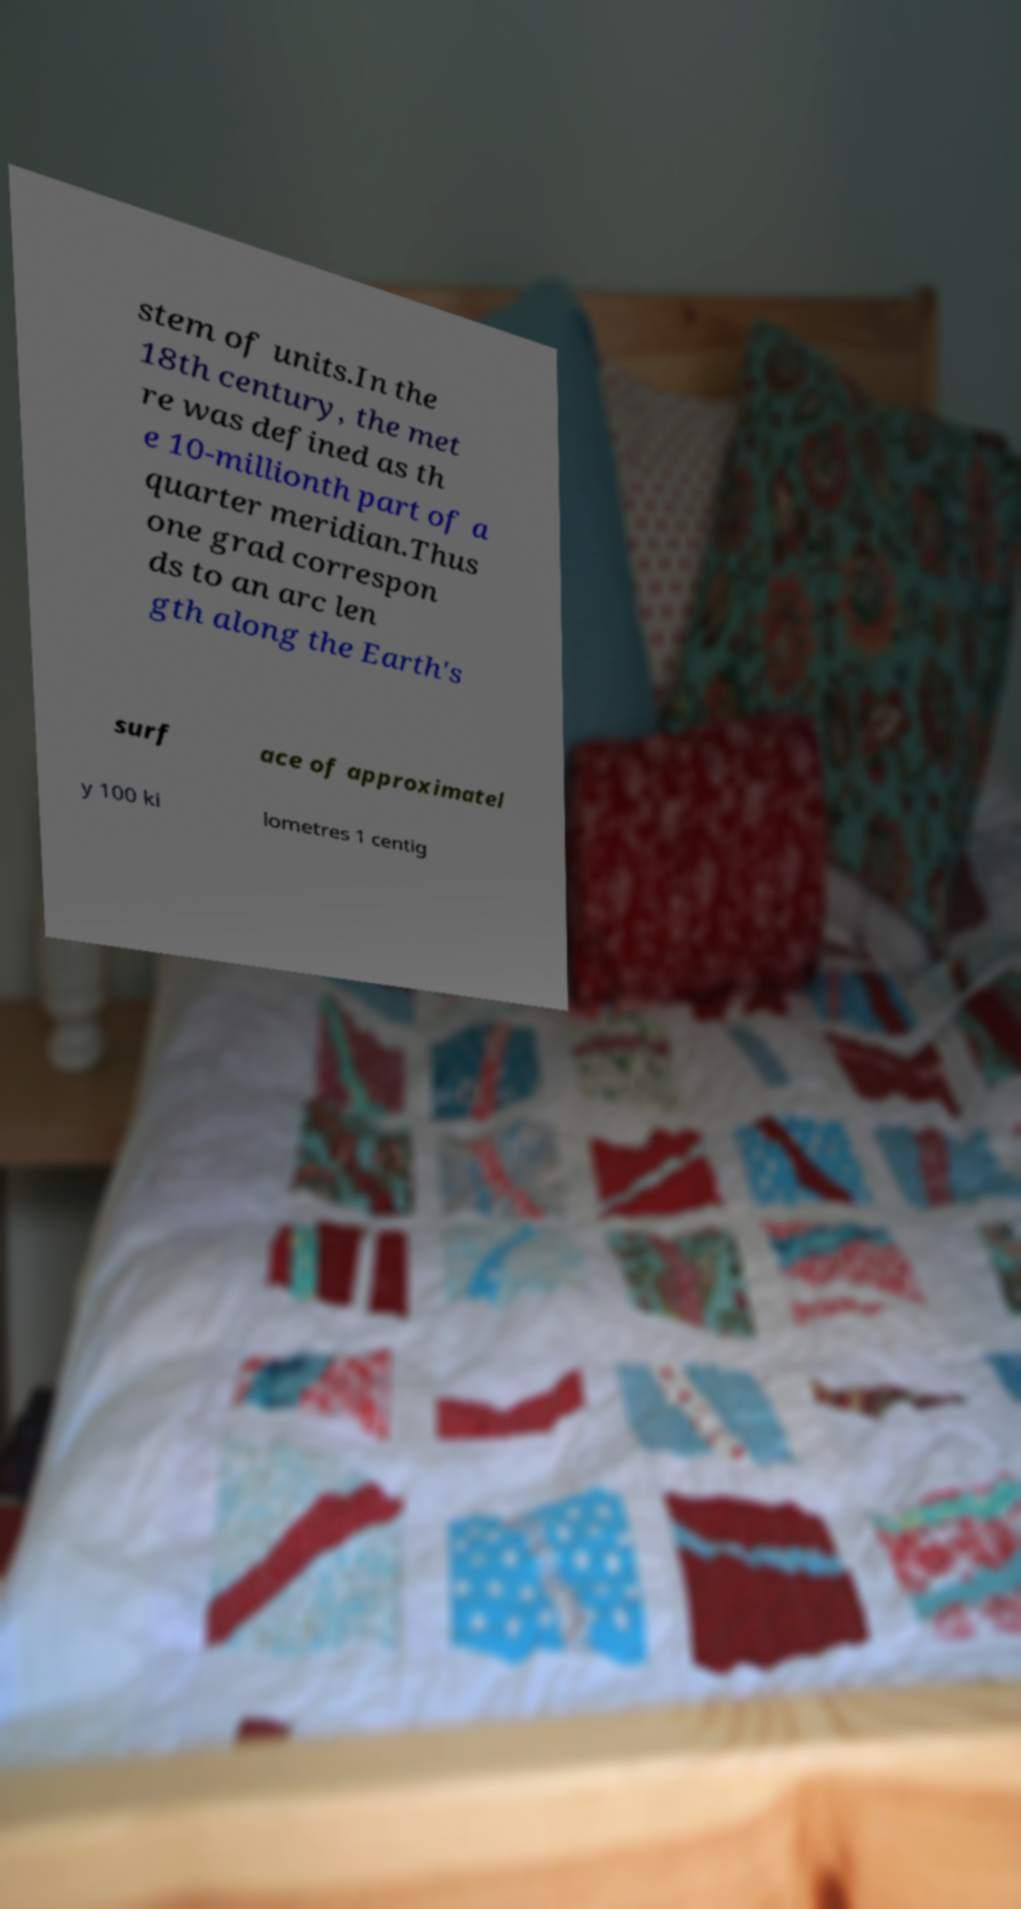For documentation purposes, I need the text within this image transcribed. Could you provide that? stem of units.In the 18th century, the met re was defined as th e 10-millionth part of a quarter meridian.Thus one grad correspon ds to an arc len gth along the Earth's surf ace of approximatel y 100 ki lometres 1 centig 